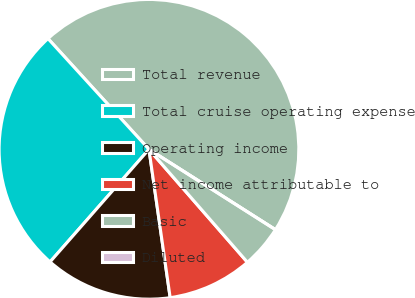Convert chart. <chart><loc_0><loc_0><loc_500><loc_500><pie_chart><fcel>Total revenue<fcel>Total cruise operating expense<fcel>Operating income<fcel>Net income attributable to<fcel>Basic<fcel>Diluted<nl><fcel>45.77%<fcel>26.76%<fcel>13.73%<fcel>9.15%<fcel>4.58%<fcel>0.0%<nl></chart> 